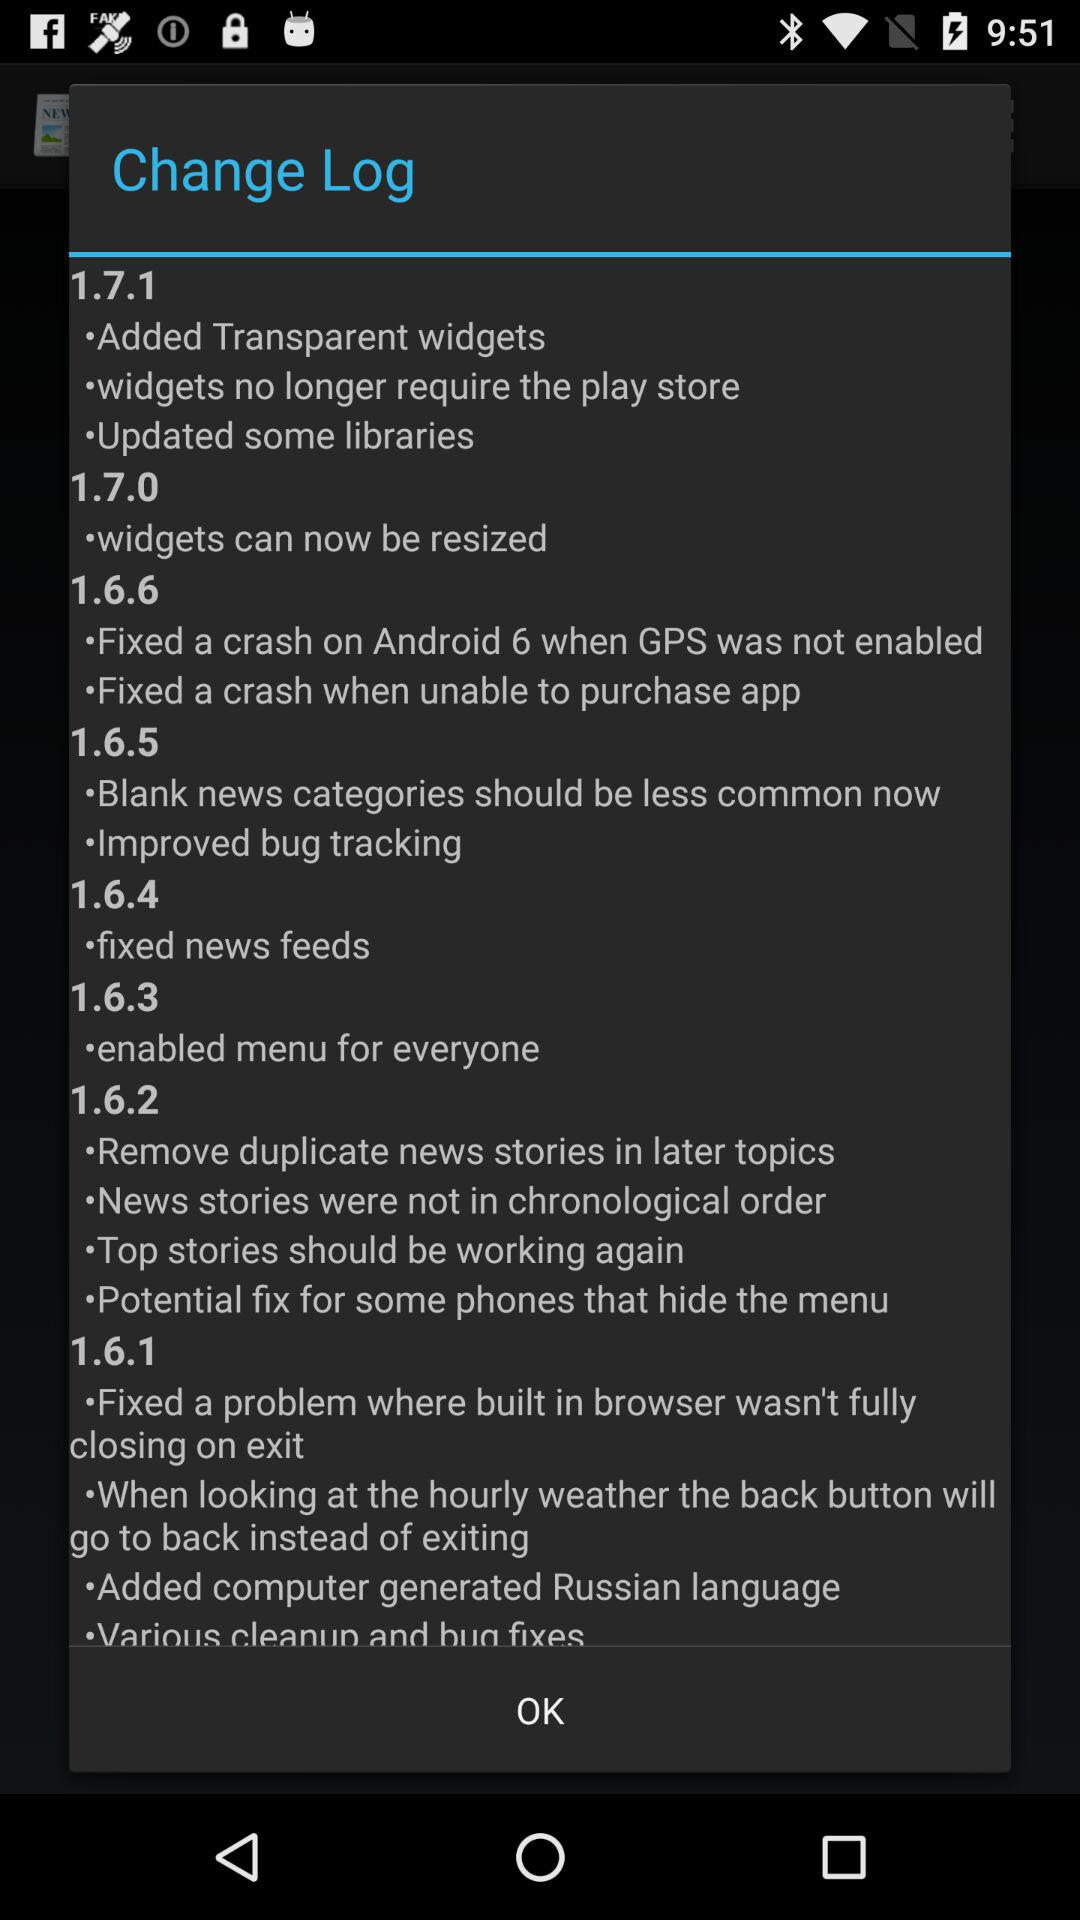What is the change in version 1.7.0? The change in version 1.7.0 is that widgets can now be resized. 